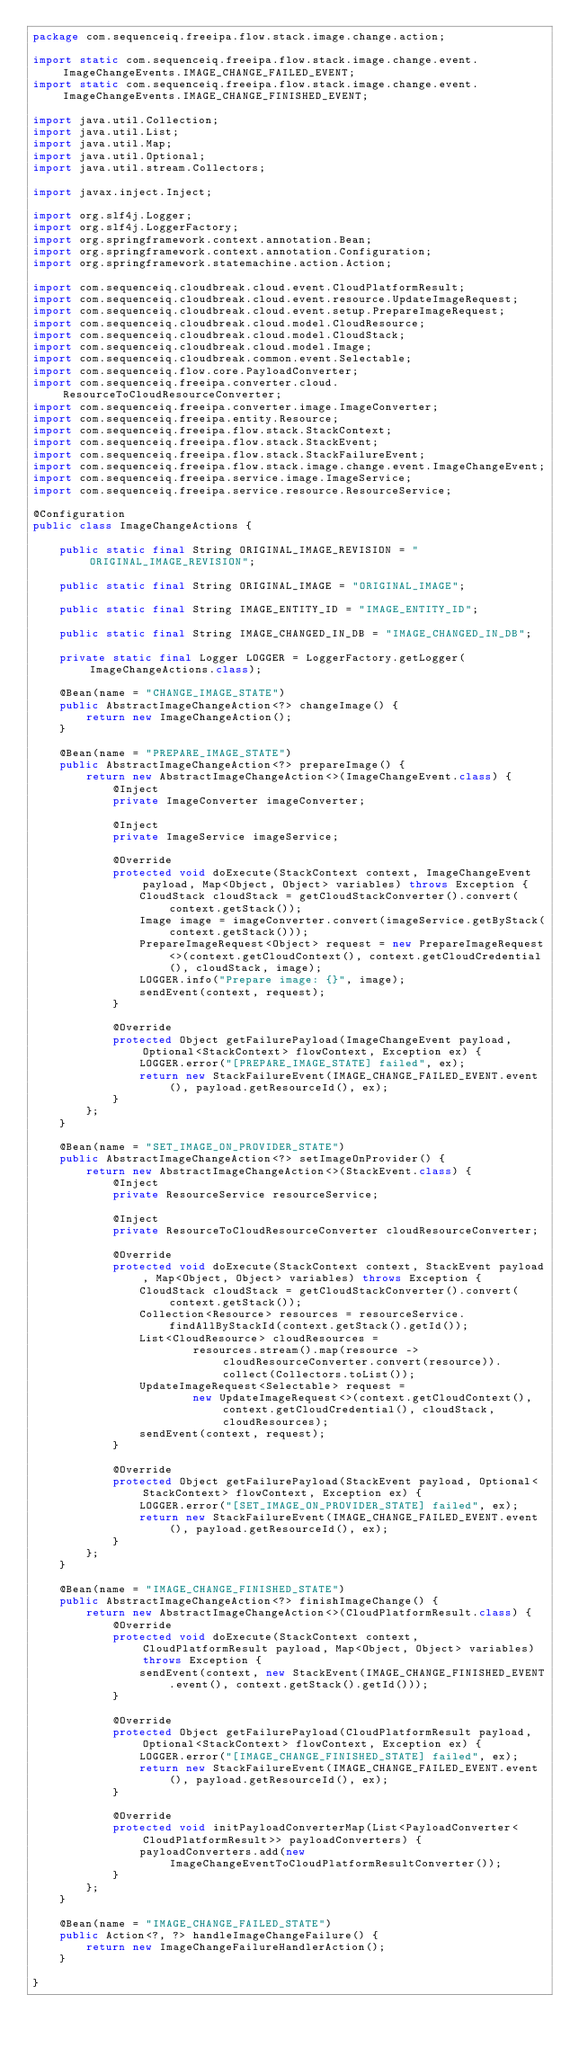<code> <loc_0><loc_0><loc_500><loc_500><_Java_>package com.sequenceiq.freeipa.flow.stack.image.change.action;

import static com.sequenceiq.freeipa.flow.stack.image.change.event.ImageChangeEvents.IMAGE_CHANGE_FAILED_EVENT;
import static com.sequenceiq.freeipa.flow.stack.image.change.event.ImageChangeEvents.IMAGE_CHANGE_FINISHED_EVENT;

import java.util.Collection;
import java.util.List;
import java.util.Map;
import java.util.Optional;
import java.util.stream.Collectors;

import javax.inject.Inject;

import org.slf4j.Logger;
import org.slf4j.LoggerFactory;
import org.springframework.context.annotation.Bean;
import org.springframework.context.annotation.Configuration;
import org.springframework.statemachine.action.Action;

import com.sequenceiq.cloudbreak.cloud.event.CloudPlatformResult;
import com.sequenceiq.cloudbreak.cloud.event.resource.UpdateImageRequest;
import com.sequenceiq.cloudbreak.cloud.event.setup.PrepareImageRequest;
import com.sequenceiq.cloudbreak.cloud.model.CloudResource;
import com.sequenceiq.cloudbreak.cloud.model.CloudStack;
import com.sequenceiq.cloudbreak.cloud.model.Image;
import com.sequenceiq.cloudbreak.common.event.Selectable;
import com.sequenceiq.flow.core.PayloadConverter;
import com.sequenceiq.freeipa.converter.cloud.ResourceToCloudResourceConverter;
import com.sequenceiq.freeipa.converter.image.ImageConverter;
import com.sequenceiq.freeipa.entity.Resource;
import com.sequenceiq.freeipa.flow.stack.StackContext;
import com.sequenceiq.freeipa.flow.stack.StackEvent;
import com.sequenceiq.freeipa.flow.stack.StackFailureEvent;
import com.sequenceiq.freeipa.flow.stack.image.change.event.ImageChangeEvent;
import com.sequenceiq.freeipa.service.image.ImageService;
import com.sequenceiq.freeipa.service.resource.ResourceService;

@Configuration
public class ImageChangeActions {

    public static final String ORIGINAL_IMAGE_REVISION = "ORIGINAL_IMAGE_REVISION";

    public static final String ORIGINAL_IMAGE = "ORIGINAL_IMAGE";

    public static final String IMAGE_ENTITY_ID = "IMAGE_ENTITY_ID";

    public static final String IMAGE_CHANGED_IN_DB = "IMAGE_CHANGED_IN_DB";

    private static final Logger LOGGER = LoggerFactory.getLogger(ImageChangeActions.class);

    @Bean(name = "CHANGE_IMAGE_STATE")
    public AbstractImageChangeAction<?> changeImage() {
        return new ImageChangeAction();
    }

    @Bean(name = "PREPARE_IMAGE_STATE")
    public AbstractImageChangeAction<?> prepareImage() {
        return new AbstractImageChangeAction<>(ImageChangeEvent.class) {
            @Inject
            private ImageConverter imageConverter;

            @Inject
            private ImageService imageService;

            @Override
            protected void doExecute(StackContext context, ImageChangeEvent payload, Map<Object, Object> variables) throws Exception {
                CloudStack cloudStack = getCloudStackConverter().convert(context.getStack());
                Image image = imageConverter.convert(imageService.getByStack(context.getStack()));
                PrepareImageRequest<Object> request = new PrepareImageRequest<>(context.getCloudContext(), context.getCloudCredential(), cloudStack, image);
                LOGGER.info("Prepare image: {}", image);
                sendEvent(context, request);
            }

            @Override
            protected Object getFailurePayload(ImageChangeEvent payload, Optional<StackContext> flowContext, Exception ex) {
                LOGGER.error("[PREPARE_IMAGE_STATE] failed", ex);
                return new StackFailureEvent(IMAGE_CHANGE_FAILED_EVENT.event(), payload.getResourceId(), ex);
            }
        };
    }

    @Bean(name = "SET_IMAGE_ON_PROVIDER_STATE")
    public AbstractImageChangeAction<?> setImageOnProvider() {
        return new AbstractImageChangeAction<>(StackEvent.class) {
            @Inject
            private ResourceService resourceService;

            @Inject
            private ResourceToCloudResourceConverter cloudResourceConverter;

            @Override
            protected void doExecute(StackContext context, StackEvent payload, Map<Object, Object> variables) throws Exception {
                CloudStack cloudStack = getCloudStackConverter().convert(context.getStack());
                Collection<Resource> resources = resourceService.findAllByStackId(context.getStack().getId());
                List<CloudResource> cloudResources =
                        resources.stream().map(resource -> cloudResourceConverter.convert(resource)).collect(Collectors.toList());
                UpdateImageRequest<Selectable> request =
                        new UpdateImageRequest<>(context.getCloudContext(), context.getCloudCredential(), cloudStack, cloudResources);
                sendEvent(context, request);
            }

            @Override
            protected Object getFailurePayload(StackEvent payload, Optional<StackContext> flowContext, Exception ex) {
                LOGGER.error("[SET_IMAGE_ON_PROVIDER_STATE] failed", ex);
                return new StackFailureEvent(IMAGE_CHANGE_FAILED_EVENT.event(), payload.getResourceId(), ex);
            }
        };
    }

    @Bean(name = "IMAGE_CHANGE_FINISHED_STATE")
    public AbstractImageChangeAction<?> finishImageChange() {
        return new AbstractImageChangeAction<>(CloudPlatformResult.class) {
            @Override
            protected void doExecute(StackContext context, CloudPlatformResult payload, Map<Object, Object> variables) throws Exception {
                sendEvent(context, new StackEvent(IMAGE_CHANGE_FINISHED_EVENT.event(), context.getStack().getId()));
            }

            @Override
            protected Object getFailurePayload(CloudPlatformResult payload, Optional<StackContext> flowContext, Exception ex) {
                LOGGER.error("[IMAGE_CHANGE_FINISHED_STATE] failed", ex);
                return new StackFailureEvent(IMAGE_CHANGE_FAILED_EVENT.event(), payload.getResourceId(), ex);
            }

            @Override
            protected void initPayloadConverterMap(List<PayloadConverter<CloudPlatformResult>> payloadConverters) {
                payloadConverters.add(new ImageChangeEventToCloudPlatformResultConverter());
            }
        };
    }

    @Bean(name = "IMAGE_CHANGE_FAILED_STATE")
    public Action<?, ?> handleImageChangeFailure() {
        return new ImageChangeFailureHandlerAction();
    }

}
</code> 